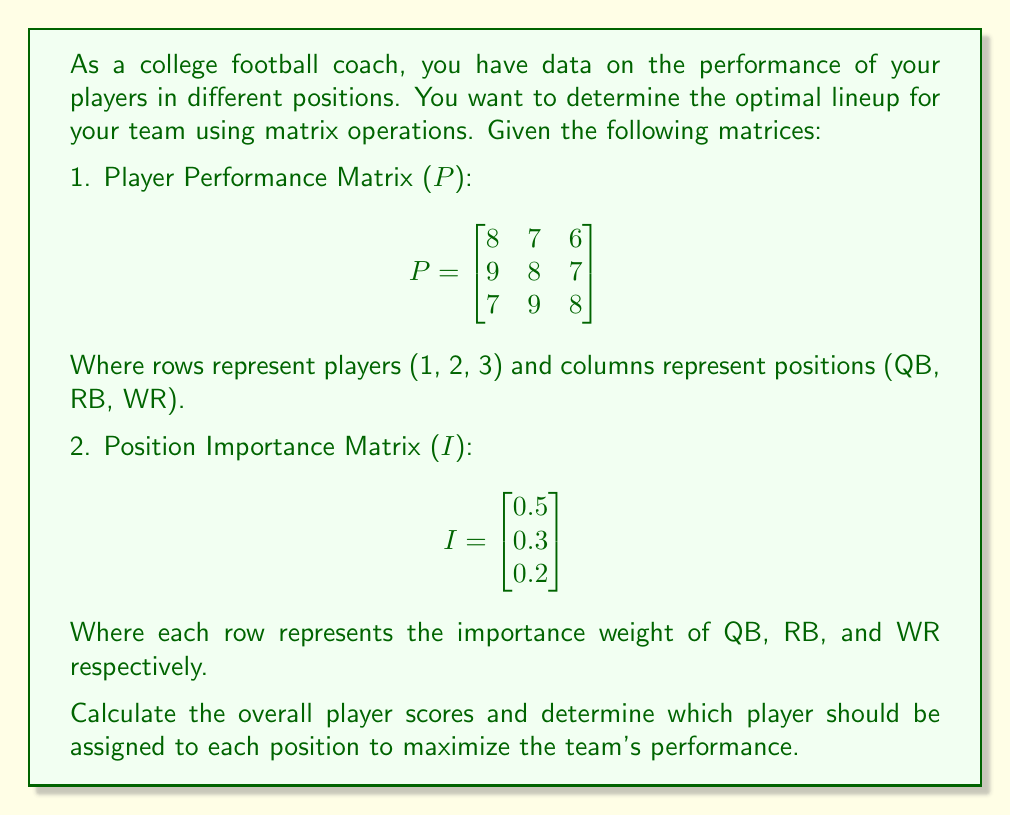Can you solve this math problem? To solve this problem, we'll use matrix multiplication to calculate the overall player scores and then analyze the results to determine the optimal lineup.

Step 1: Calculate the overall player scores
We multiply the Player Performance Matrix (P) by the Position Importance Matrix (I) to get a vector of overall player scores.

$$S = P \times I$$

$$S = \begin{bmatrix}
8 & 7 & 6 \\
9 & 8 & 7 \\
7 & 9 & 8
\end{bmatrix} \times \begin{bmatrix}
0.5 \\
0.3 \\
0.2
\end{bmatrix}$$

$$S = \begin{bmatrix}
(8 \times 0.5) + (7 \times 0.3) + (6 \times 0.2) \\
(9 \times 0.5) + (8 \times 0.3) + (7 \times 0.2) \\
(7 \times 0.5) + (9 \times 0.3) + (8 \times 0.2)
\end{bmatrix}$$

$$S = \begin{bmatrix}
7.3 \\
8.3 \\
7.7
\end{bmatrix}$$

Step 2: Analyze the results
The overall player scores are:
Player 1: 7.3
Player 2: 8.3
Player 3: 7.7

To maximize team performance, we should assign:
- The highest-scoring player (Player 2) to the most important position (QB)
- The second-highest scoring player (Player 3) to the second most important position (RB)
- The remaining player (Player 1) to the least important position (WR)

Step 3: Verify the assignments
Check the original Player Performance Matrix to ensure these assignments align with individual position strengths:

Player 2 (QB): 9 (highest score for QB)
Player 3 (RB): 9 (highest score for RB)
Player 1 (WR): 6 (remaining player)

This assignment maximizes both overall player scores and individual position strengths.
Answer: The optimal lineup is:
QB: Player 2
RB: Player 3
WR: Player 1 